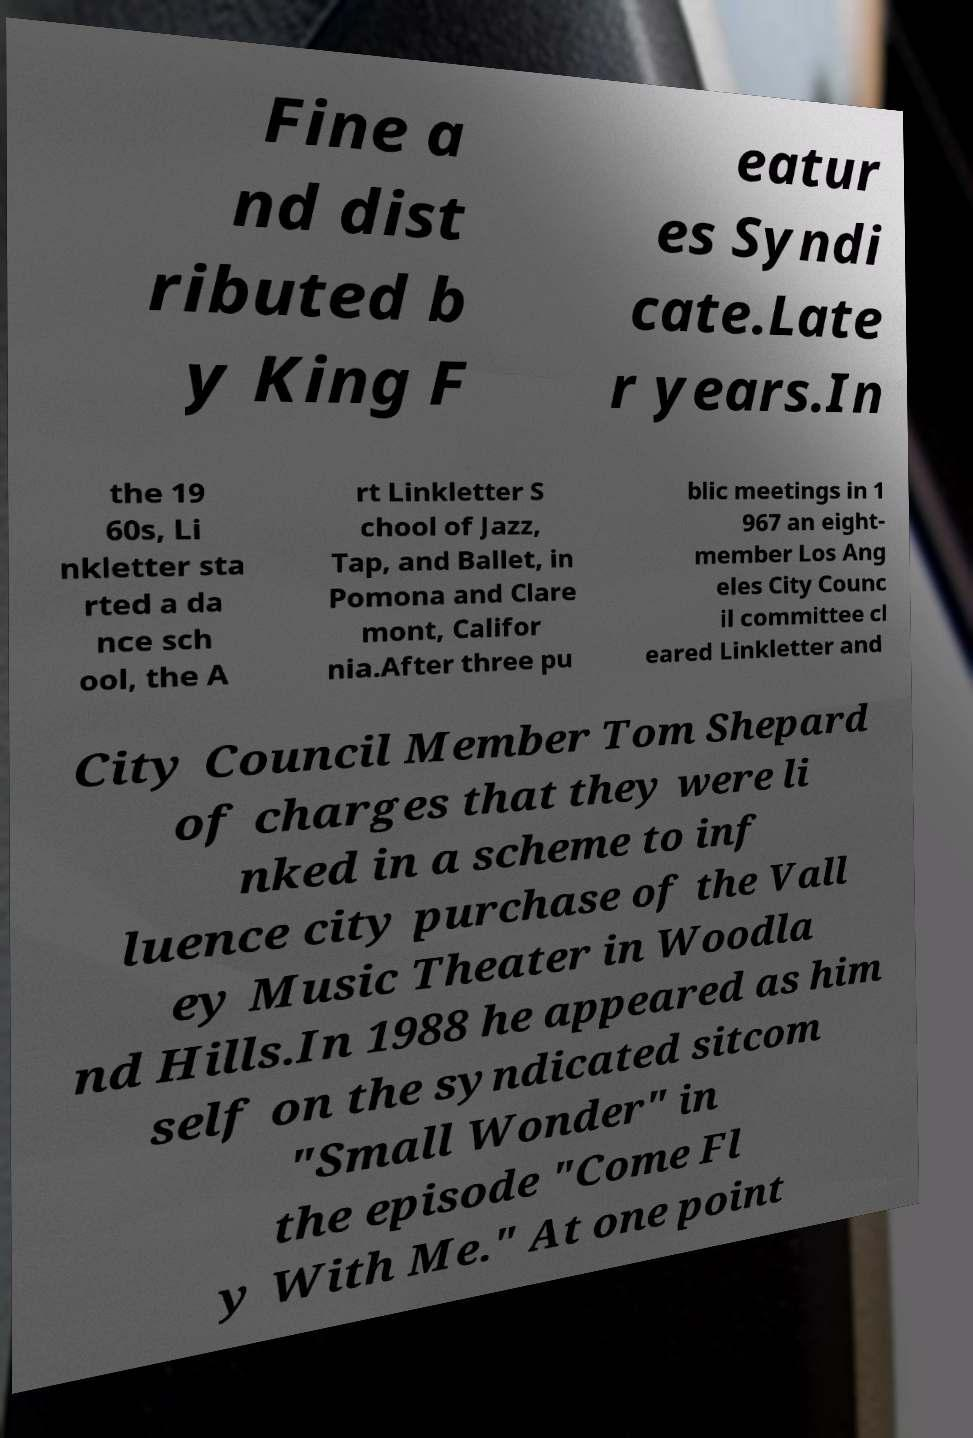Please read and relay the text visible in this image. What does it say? Fine a nd dist ributed b y King F eatur es Syndi cate.Late r years.In the 19 60s, Li nkletter sta rted a da nce sch ool, the A rt Linkletter S chool of Jazz, Tap, and Ballet, in Pomona and Clare mont, Califor nia.After three pu blic meetings in 1 967 an eight- member Los Ang eles City Counc il committee cl eared Linkletter and City Council Member Tom Shepard of charges that they were li nked in a scheme to inf luence city purchase of the Vall ey Music Theater in Woodla nd Hills.In 1988 he appeared as him self on the syndicated sitcom "Small Wonder" in the episode "Come Fl y With Me." At one point 